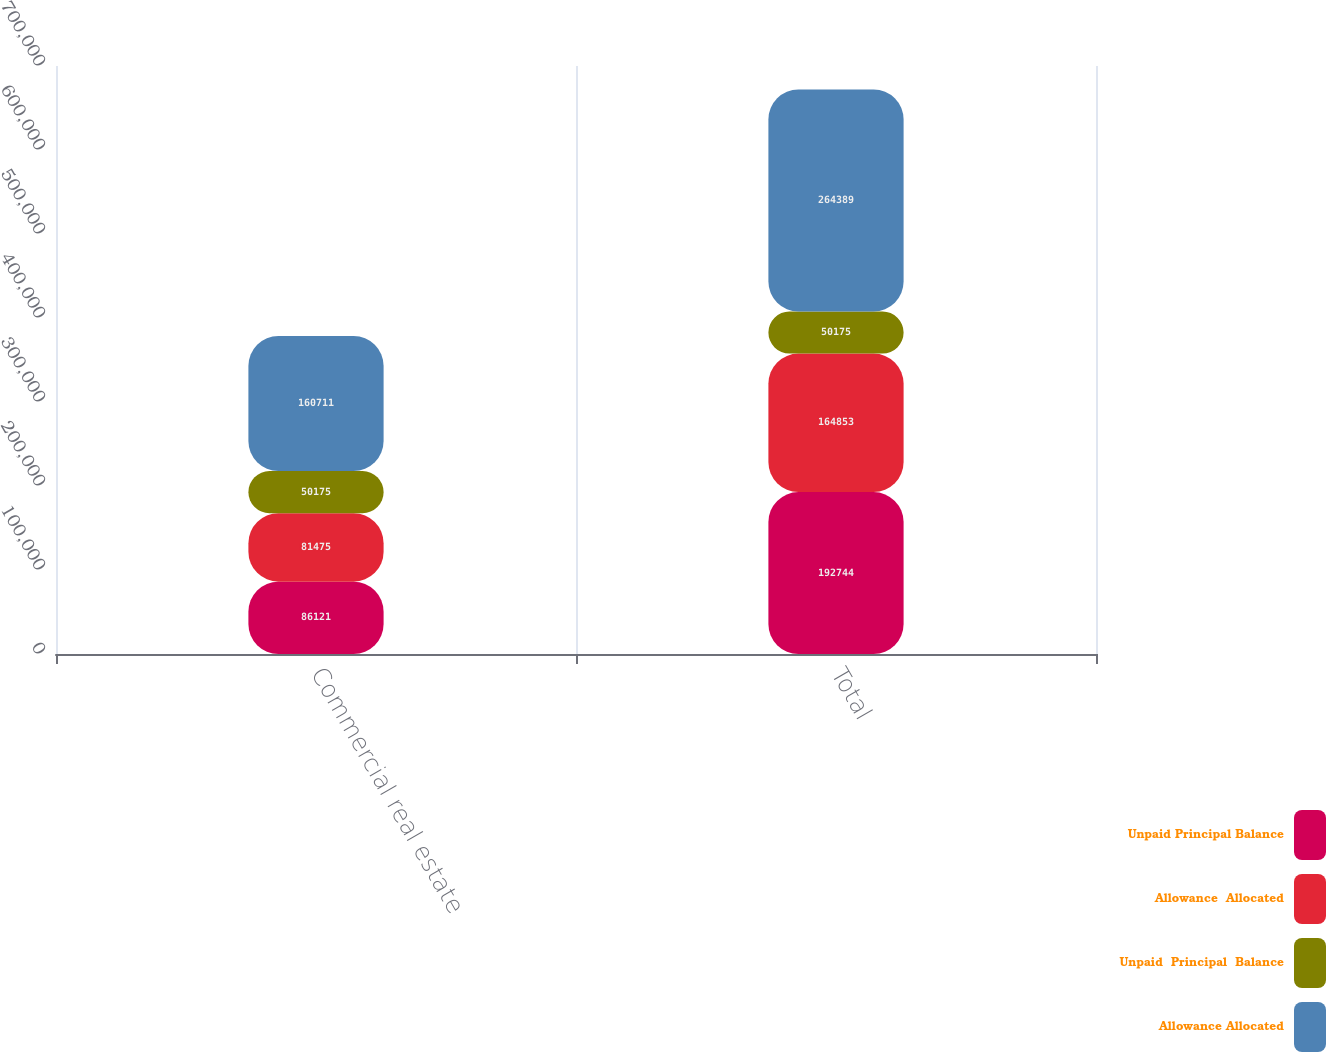<chart> <loc_0><loc_0><loc_500><loc_500><stacked_bar_chart><ecel><fcel>Commercial real estate<fcel>Total<nl><fcel>Unpaid Principal Balance<fcel>86121<fcel>192744<nl><fcel>Allowance  Allocated<fcel>81475<fcel>164853<nl><fcel>Unpaid  Principal  Balance<fcel>50175<fcel>50175<nl><fcel>Allowance Allocated<fcel>160711<fcel>264389<nl></chart> 